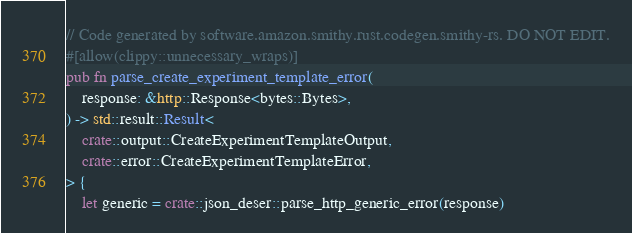Convert code to text. <code><loc_0><loc_0><loc_500><loc_500><_Rust_>// Code generated by software.amazon.smithy.rust.codegen.smithy-rs. DO NOT EDIT.
#[allow(clippy::unnecessary_wraps)]
pub fn parse_create_experiment_template_error(
    response: &http::Response<bytes::Bytes>,
) -> std::result::Result<
    crate::output::CreateExperimentTemplateOutput,
    crate::error::CreateExperimentTemplateError,
> {
    let generic = crate::json_deser::parse_http_generic_error(response)</code> 